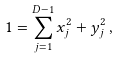Convert formula to latex. <formula><loc_0><loc_0><loc_500><loc_500>1 = \sum _ { j = 1 } ^ { D - 1 } x _ { j } ^ { 2 } + y _ { j } ^ { 2 } \, ,</formula> 